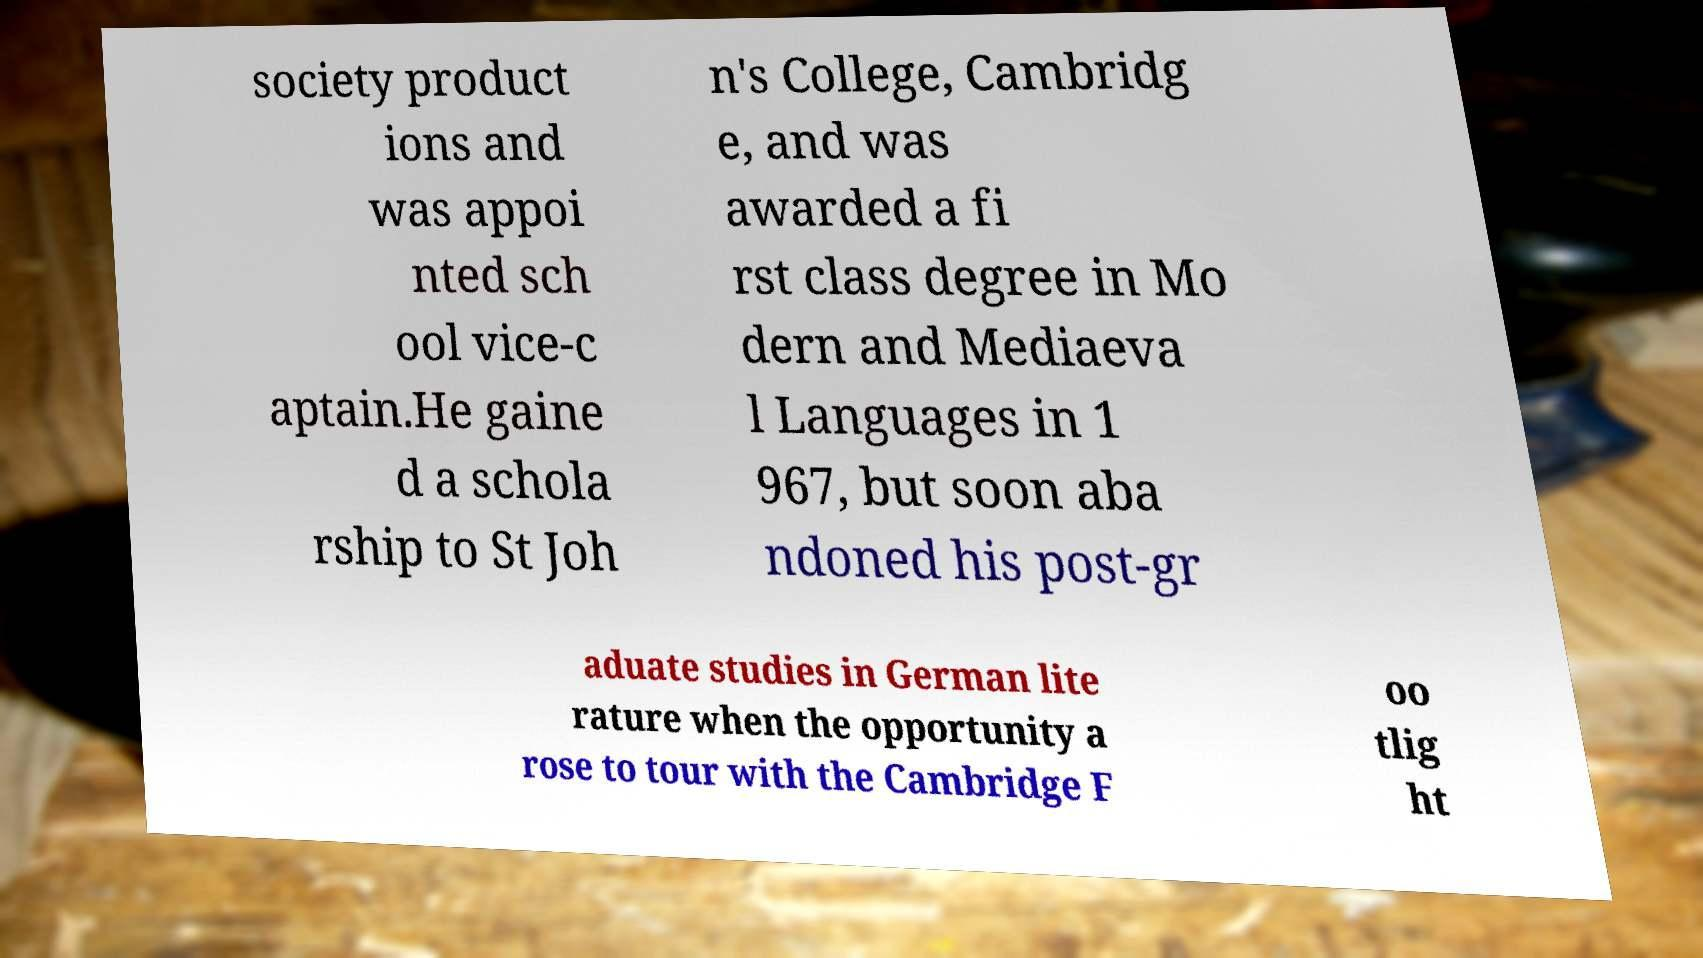Could you assist in decoding the text presented in this image and type it out clearly? society product ions and was appoi nted sch ool vice-c aptain.He gaine d a schola rship to St Joh n's College, Cambridg e, and was awarded a fi rst class degree in Mo dern and Mediaeva l Languages in 1 967, but soon aba ndoned his post-gr aduate studies in German lite rature when the opportunity a rose to tour with the Cambridge F oo tlig ht 